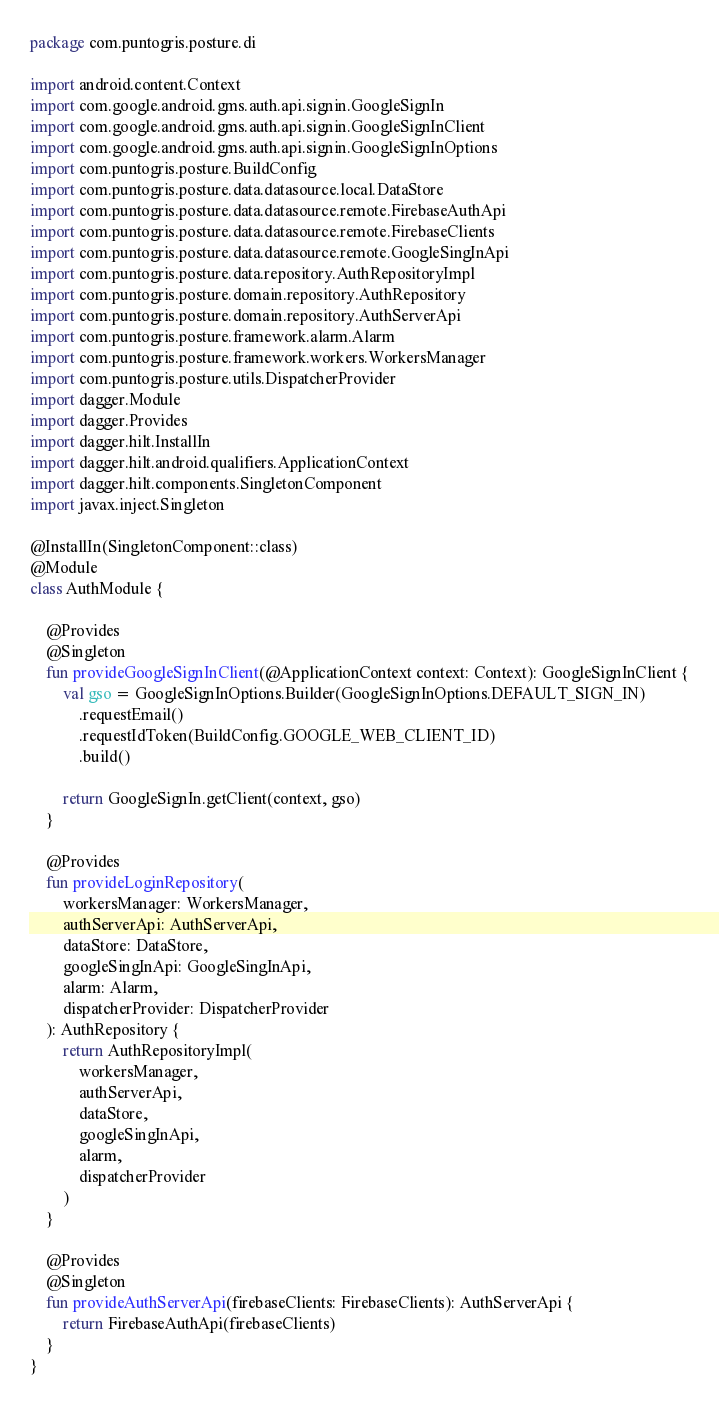<code> <loc_0><loc_0><loc_500><loc_500><_Kotlin_>package com.puntogris.posture.di

import android.content.Context
import com.google.android.gms.auth.api.signin.GoogleSignIn
import com.google.android.gms.auth.api.signin.GoogleSignInClient
import com.google.android.gms.auth.api.signin.GoogleSignInOptions
import com.puntogris.posture.BuildConfig
import com.puntogris.posture.data.datasource.local.DataStore
import com.puntogris.posture.data.datasource.remote.FirebaseAuthApi
import com.puntogris.posture.data.datasource.remote.FirebaseClients
import com.puntogris.posture.data.datasource.remote.GoogleSingInApi
import com.puntogris.posture.data.repository.AuthRepositoryImpl
import com.puntogris.posture.domain.repository.AuthRepository
import com.puntogris.posture.domain.repository.AuthServerApi
import com.puntogris.posture.framework.alarm.Alarm
import com.puntogris.posture.framework.workers.WorkersManager
import com.puntogris.posture.utils.DispatcherProvider
import dagger.Module
import dagger.Provides
import dagger.hilt.InstallIn
import dagger.hilt.android.qualifiers.ApplicationContext
import dagger.hilt.components.SingletonComponent
import javax.inject.Singleton

@InstallIn(SingletonComponent::class)
@Module
class AuthModule {

    @Provides
    @Singleton
    fun provideGoogleSignInClient(@ApplicationContext context: Context): GoogleSignInClient {
        val gso = GoogleSignInOptions.Builder(GoogleSignInOptions.DEFAULT_SIGN_IN)
            .requestEmail()
            .requestIdToken(BuildConfig.GOOGLE_WEB_CLIENT_ID)
            .build()

        return GoogleSignIn.getClient(context, gso)
    }

    @Provides
    fun provideLoginRepository(
        workersManager: WorkersManager,
        authServerApi: AuthServerApi,
        dataStore: DataStore,
        googleSingInApi: GoogleSingInApi,
        alarm: Alarm,
        dispatcherProvider: DispatcherProvider
    ): AuthRepository {
        return AuthRepositoryImpl(
            workersManager,
            authServerApi,
            dataStore,
            googleSingInApi,
            alarm,
            dispatcherProvider
        )
    }

    @Provides
    @Singleton
    fun provideAuthServerApi(firebaseClients: FirebaseClients): AuthServerApi {
        return FirebaseAuthApi(firebaseClients)
    }
}</code> 